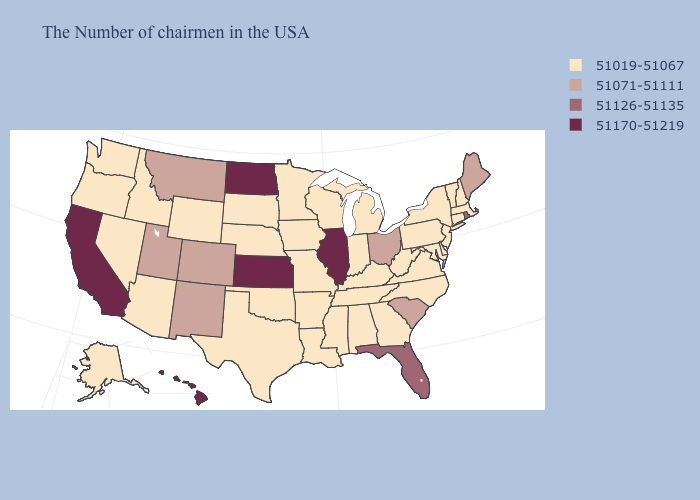How many symbols are there in the legend?
Short answer required. 4. Name the states that have a value in the range 51071-51111?
Quick response, please. Maine, South Carolina, Ohio, Colorado, New Mexico, Utah, Montana. What is the highest value in states that border North Dakota?
Give a very brief answer. 51071-51111. Does Colorado have a higher value than Connecticut?
Concise answer only. Yes. Does the map have missing data?
Answer briefly. No. What is the lowest value in the USA?
Write a very short answer. 51019-51067. Does Massachusetts have a lower value than New Mexico?
Write a very short answer. Yes. Name the states that have a value in the range 51071-51111?
Give a very brief answer. Maine, South Carolina, Ohio, Colorado, New Mexico, Utah, Montana. Name the states that have a value in the range 51170-51219?
Be succinct. Illinois, Kansas, North Dakota, California, Hawaii. Which states have the lowest value in the Northeast?
Keep it brief. Massachusetts, New Hampshire, Vermont, Connecticut, New York, New Jersey, Pennsylvania. Name the states that have a value in the range 51126-51135?
Keep it brief. Rhode Island, Florida. Name the states that have a value in the range 51019-51067?
Short answer required. Massachusetts, New Hampshire, Vermont, Connecticut, New York, New Jersey, Delaware, Maryland, Pennsylvania, Virginia, North Carolina, West Virginia, Georgia, Michigan, Kentucky, Indiana, Alabama, Tennessee, Wisconsin, Mississippi, Louisiana, Missouri, Arkansas, Minnesota, Iowa, Nebraska, Oklahoma, Texas, South Dakota, Wyoming, Arizona, Idaho, Nevada, Washington, Oregon, Alaska. What is the value of Colorado?
Quick response, please. 51071-51111. What is the value of Missouri?
Short answer required. 51019-51067. What is the lowest value in states that border North Carolina?
Answer briefly. 51019-51067. 